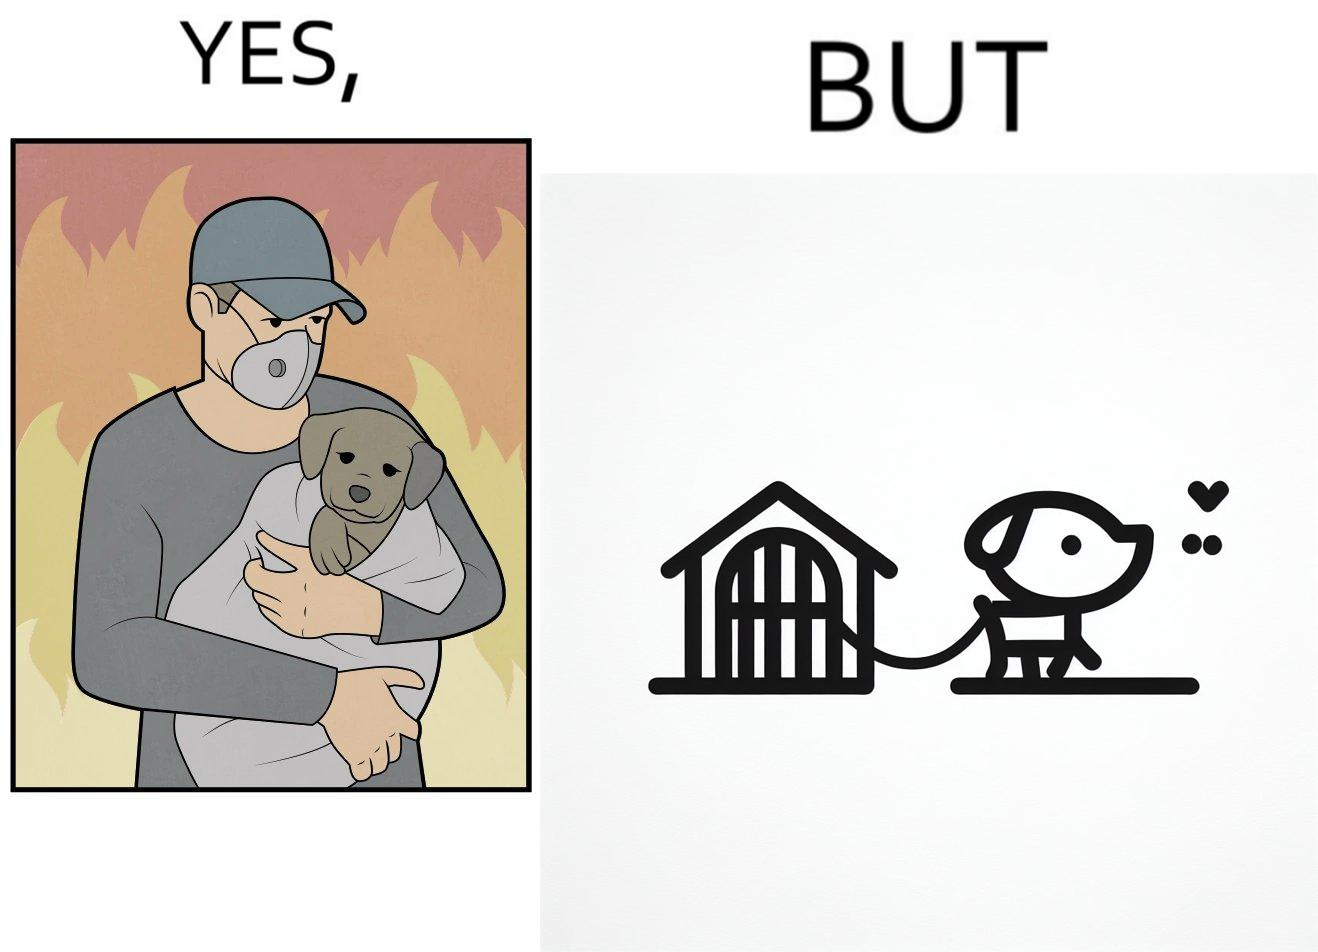Describe the content of this image. The image is ironic, because in the left image the man is showing love and care for the puppy but in the right image the same puppy is shown to be chained in a kennel, which shows dual nature of human towards animals 